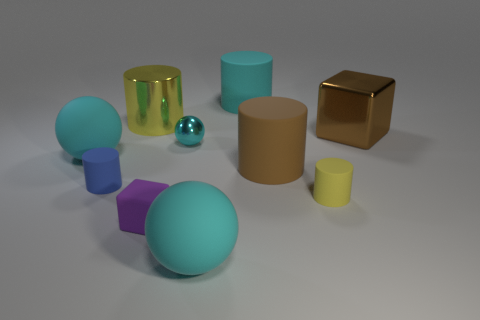Subtract 2 cylinders. How many cylinders are left? 3 Subtract all green cylinders. Subtract all brown blocks. How many cylinders are left? 5 Subtract all blocks. How many objects are left? 8 Subtract all big metal blocks. Subtract all blue cylinders. How many objects are left? 8 Add 6 cubes. How many cubes are left? 8 Add 2 small objects. How many small objects exist? 6 Subtract 1 blue cylinders. How many objects are left? 9 